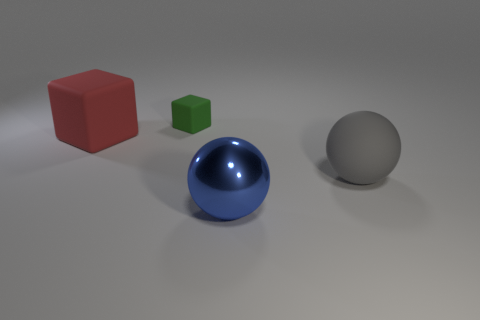Is there any other thing that is made of the same material as the small green object?
Your answer should be very brief. Yes. Is the size of the blue ball the same as the red matte object?
Ensure brevity in your answer.  Yes. Is the size of the sphere that is in front of the large gray ball the same as the thing right of the large metallic object?
Provide a short and direct response. Yes. How many things are either large objects on the right side of the small green rubber thing or rubber blocks in front of the tiny matte block?
Provide a succinct answer. 3. Is there anything else that has the same shape as the blue thing?
Provide a short and direct response. Yes. Is the color of the big thing right of the blue sphere the same as the big rubber object that is to the left of the metallic ball?
Your answer should be compact. No. What number of matte objects are either green things or big red blocks?
Provide a short and direct response. 2. Is there anything else that has the same size as the blue sphere?
Keep it short and to the point. Yes. What shape is the big thing that is in front of the big object on the right side of the blue metallic thing?
Give a very brief answer. Sphere. Do the thing that is right of the shiny object and the large thing to the left of the small green block have the same material?
Offer a very short reply. Yes. 